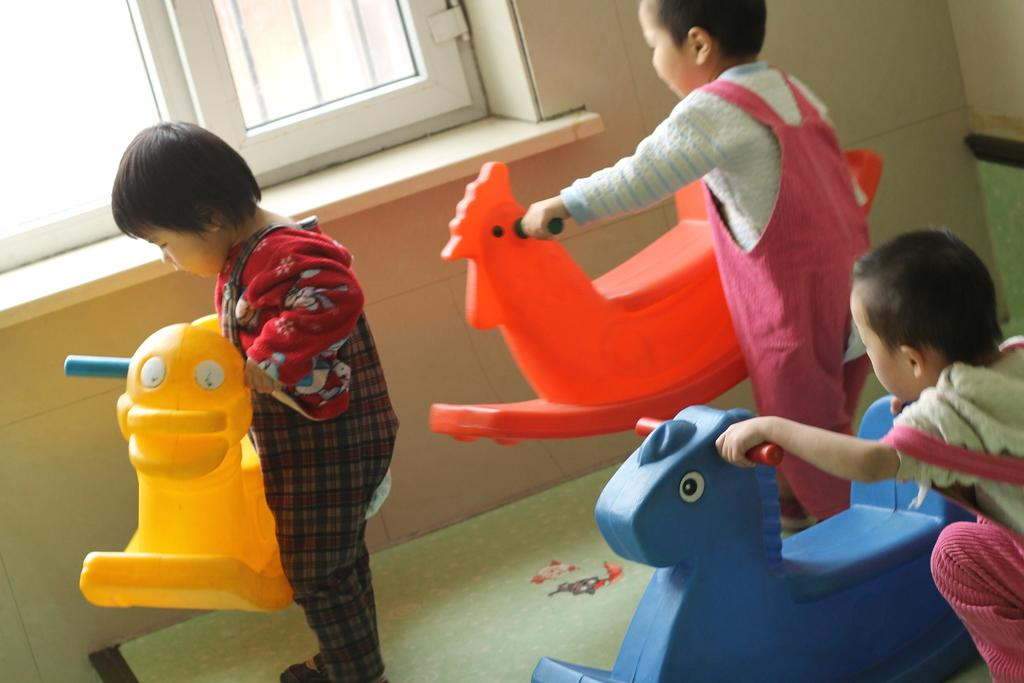How many children are present in the image? There are three children in the image. What are the children doing in the image? The children are playing with toys. What colors are the toys that the children are playing with? The toys are yellow, red, and blue in color. What can be seen in the background of the image? There is a wall and a window in the background of the image. Are the giants in the image trying to stop the children from playing with the toys? There are no giants present in the image, so it is not possible to answer that question. 